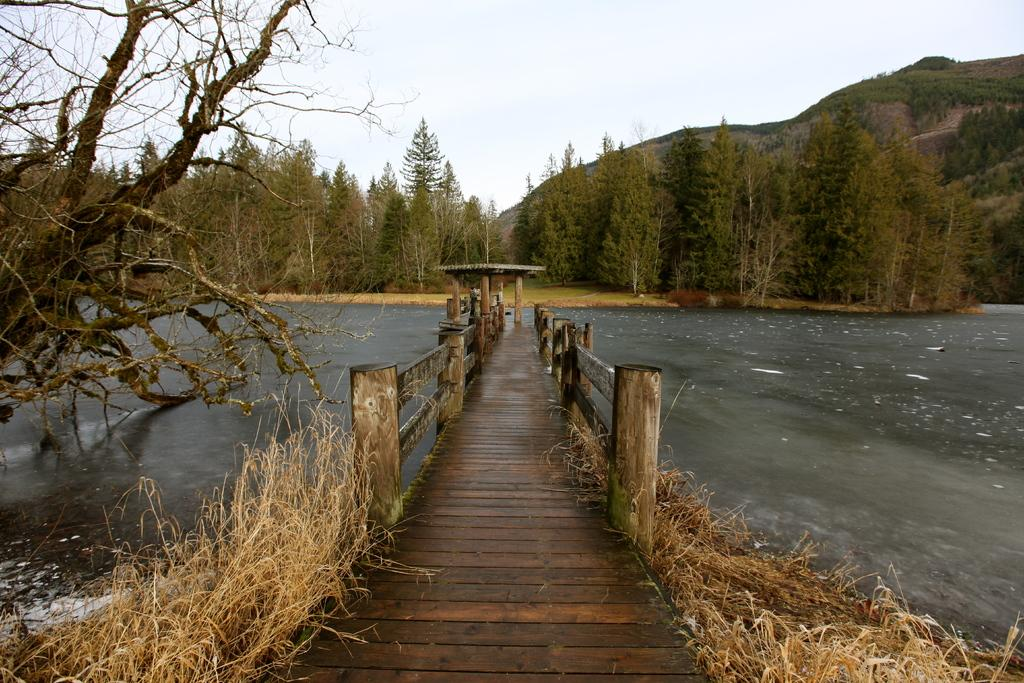What type of bridge is in the center of the image? There is a board bridge in the center of the image. What can be seen in the background of the image? There are trees, hills, and plants in the background of the image. What is visible in the image besides the bridge? Water is visible in the image, as well as the sky at the top. What type of question is being asked by the fang in the image? There is no fang present in the image, and therefore no such question can be asked. 